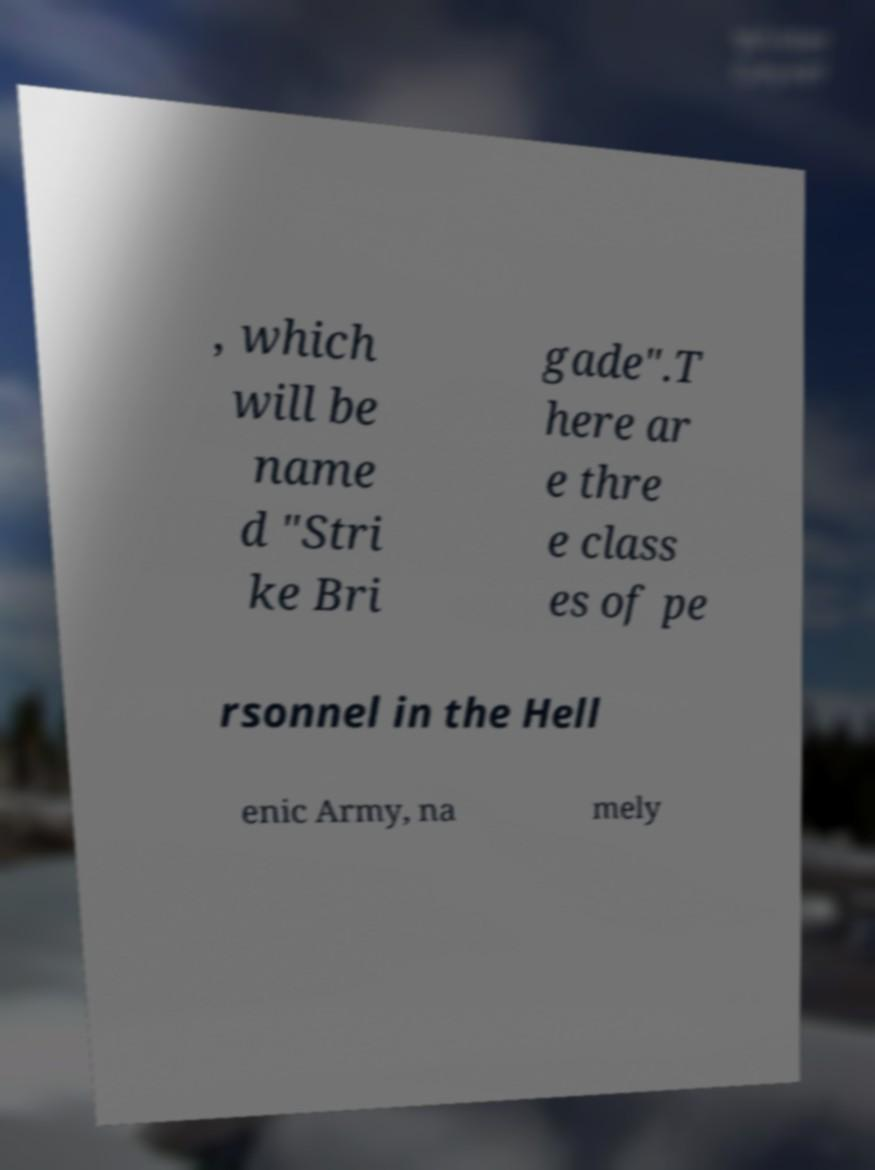Please identify and transcribe the text found in this image. , which will be name d "Stri ke Bri gade".T here ar e thre e class es of pe rsonnel in the Hell enic Army, na mely 